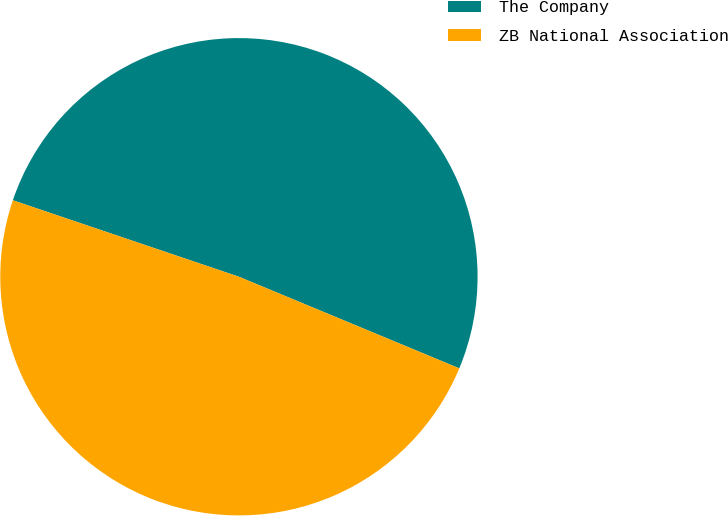Convert chart. <chart><loc_0><loc_0><loc_500><loc_500><pie_chart><fcel>The Company<fcel>ZB National Association<nl><fcel>51.08%<fcel>48.92%<nl></chart> 